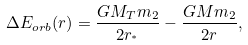Convert formula to latex. <formula><loc_0><loc_0><loc_500><loc_500>\Delta { E _ { o r b } } ( r ) = \frac { G M _ { T } m _ { 2 } } { 2 r _ { ^ { * } } } - \frac { G M m _ { 2 } } { 2 r } ,</formula> 